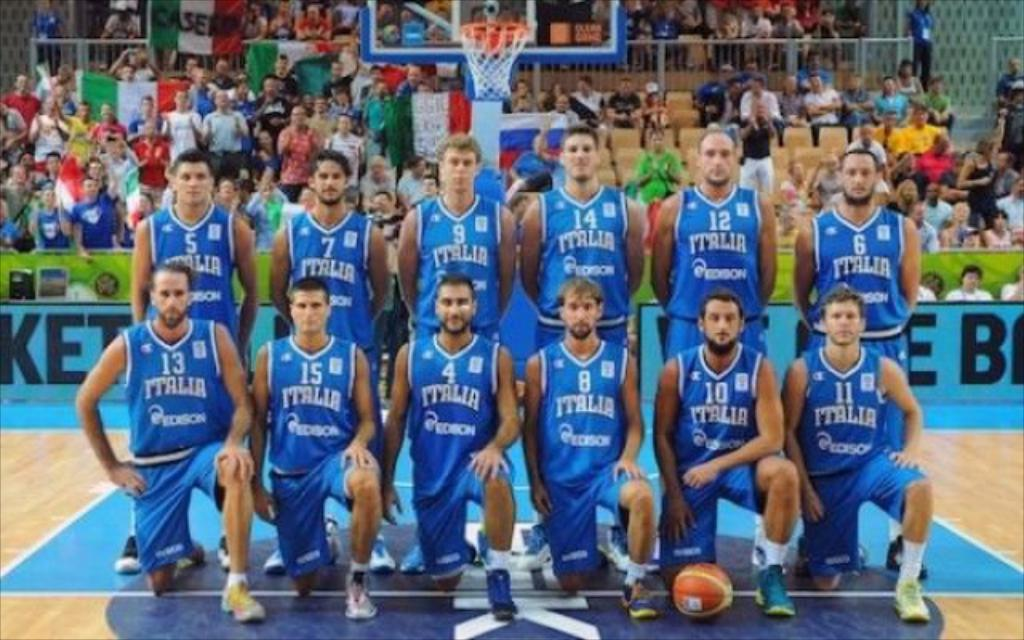<image>
Describe the image concisely. Members of the Italian national basketball team pose for a group photo on a basketball court. 